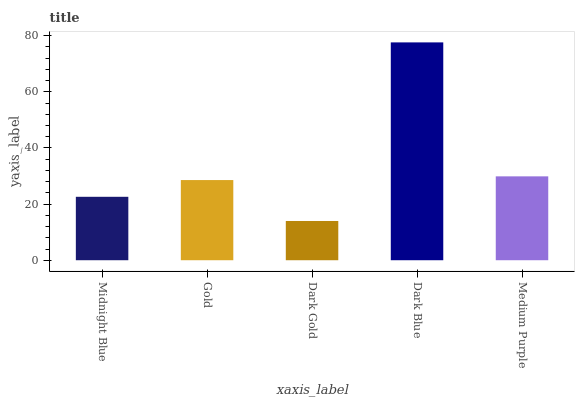Is Dark Gold the minimum?
Answer yes or no. Yes. Is Dark Blue the maximum?
Answer yes or no. Yes. Is Gold the minimum?
Answer yes or no. No. Is Gold the maximum?
Answer yes or no. No. Is Gold greater than Midnight Blue?
Answer yes or no. Yes. Is Midnight Blue less than Gold?
Answer yes or no. Yes. Is Midnight Blue greater than Gold?
Answer yes or no. No. Is Gold less than Midnight Blue?
Answer yes or no. No. Is Gold the high median?
Answer yes or no. Yes. Is Gold the low median?
Answer yes or no. Yes. Is Dark Blue the high median?
Answer yes or no. No. Is Dark Gold the low median?
Answer yes or no. No. 